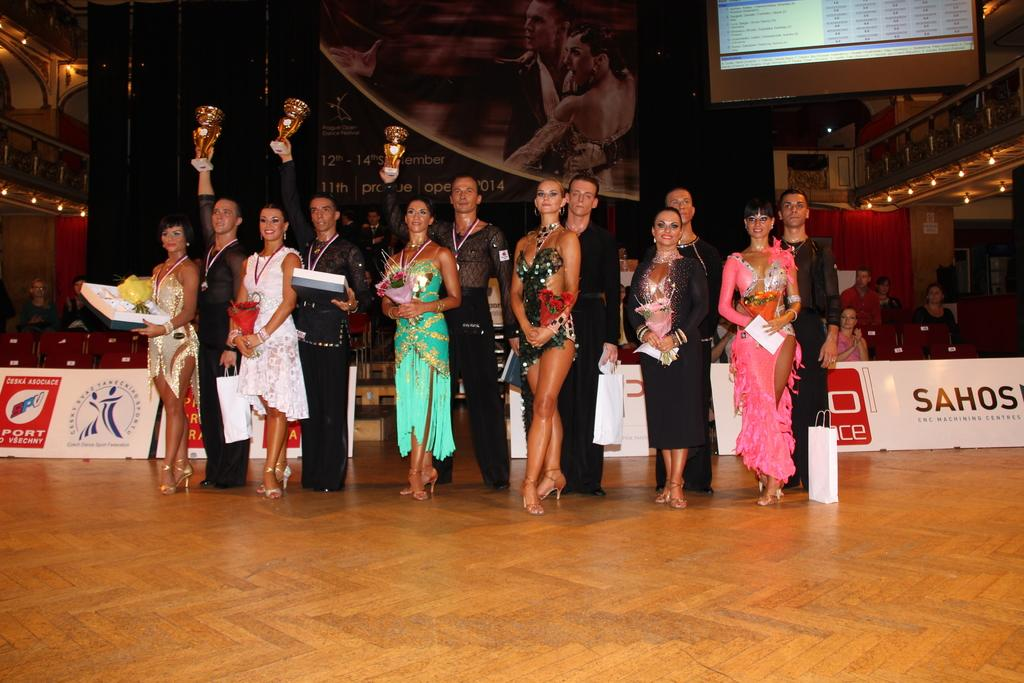What can be seen in the front of the image? There are people standing in the front of the image. What type of signage is present in the image? There are banners in the image. What is the purpose of the screen in the image? The screen in the image is likely used for displaying information or visuals. What type of lighting is present in the image? There are lights in the image, which could be for illumination or decorative purposes. What type of seating is available in the image? There are chairs in the image, which could be for people to sit on. What time of day is it in the image, considering the presence of winter? The image does not provide any information about the time of day or the presence of winter. What type of blade is being used by the people in the image? There is no blade present in the image; the people are simply appear to be standing. 